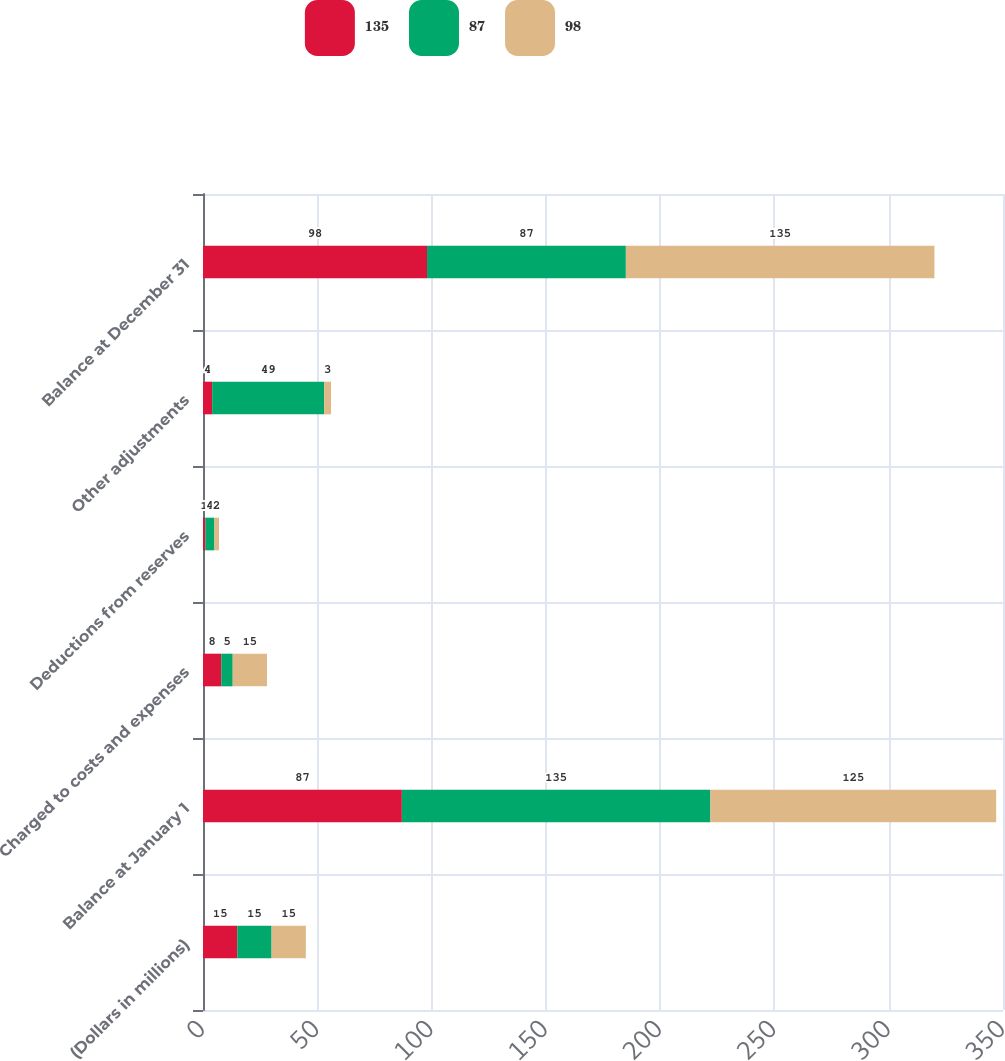Convert chart to OTSL. <chart><loc_0><loc_0><loc_500><loc_500><stacked_bar_chart><ecel><fcel>(Dollars in millions)<fcel>Balance at January 1<fcel>Charged to costs and expenses<fcel>Deductions from reserves<fcel>Other adjustments<fcel>Balance at December 31<nl><fcel>135<fcel>15<fcel>87<fcel>8<fcel>1<fcel>4<fcel>98<nl><fcel>87<fcel>15<fcel>135<fcel>5<fcel>4<fcel>49<fcel>87<nl><fcel>98<fcel>15<fcel>125<fcel>15<fcel>2<fcel>3<fcel>135<nl></chart> 